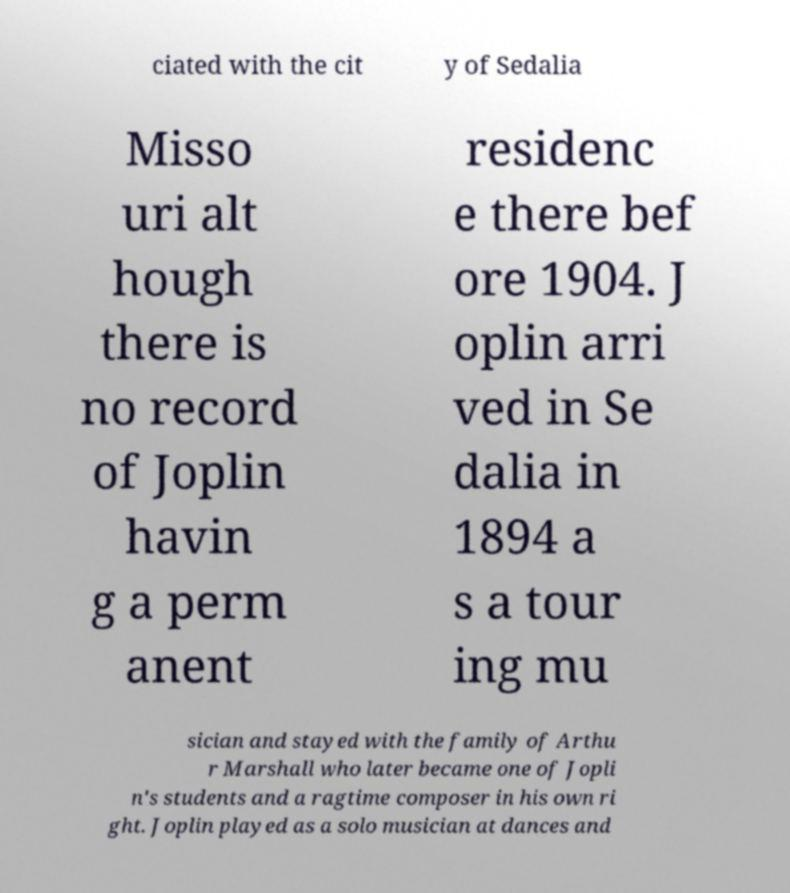Can you accurately transcribe the text from the provided image for me? ciated with the cit y of Sedalia Misso uri alt hough there is no record of Joplin havin g a perm anent residenc e there bef ore 1904. J oplin arri ved in Se dalia in 1894 a s a tour ing mu sician and stayed with the family of Arthu r Marshall who later became one of Jopli n's students and a ragtime composer in his own ri ght. Joplin played as a solo musician at dances and 